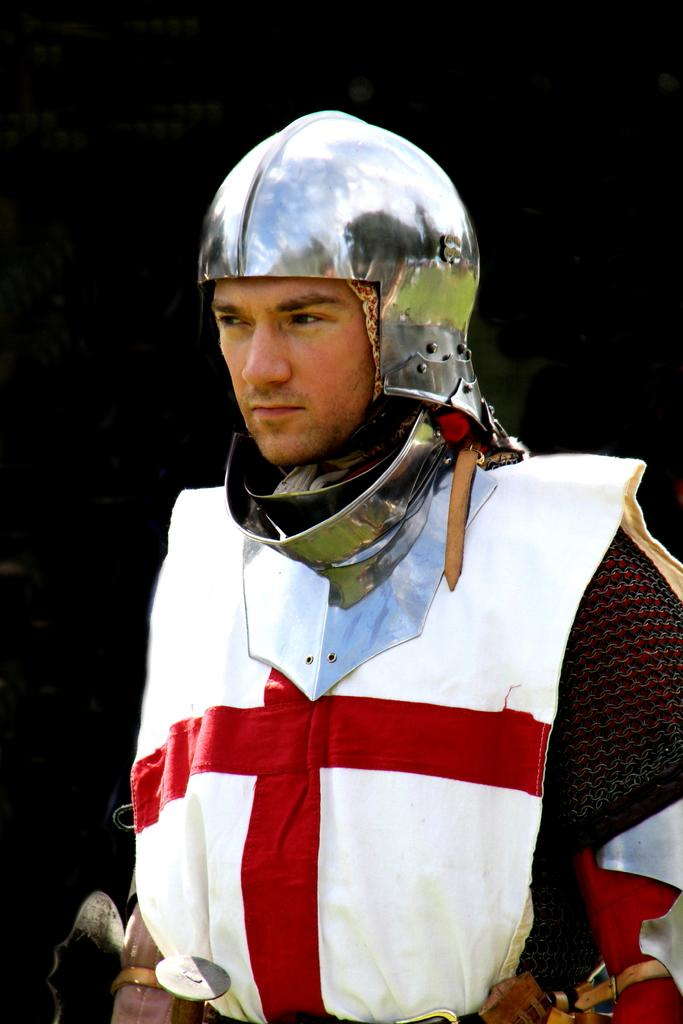Who is present in the image? There is a man in the picture. What is the man wearing on his head? The man is wearing a helmet. What can be observed about the background of the image? The background of the image is dark. What type of shoe is the man wearing in the image? There is no information about the man's shoes in the image, so we cannot determine the type of shoe he is wearing. 